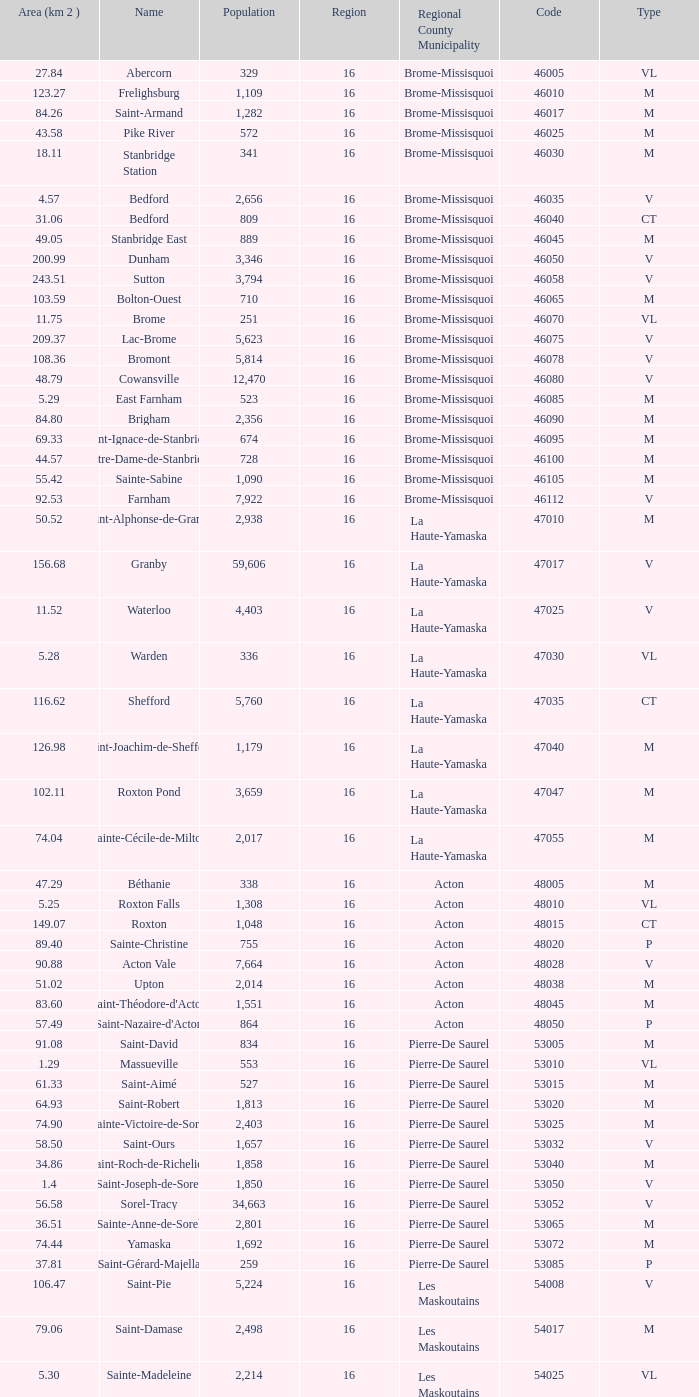Saint-Blaise-Sur-Richelieu is smaller than 68.42 km^2, what is the population of this type M municipality? None. 